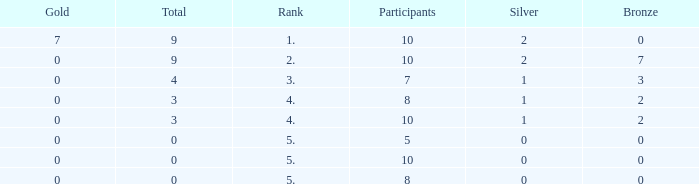What is the total number of Participants that has Silver that's smaller than 0? None. Parse the full table. {'header': ['Gold', 'Total', 'Rank', 'Participants', 'Silver', 'Bronze'], 'rows': [['7', '9', '1.', '10', '2', '0'], ['0', '9', '2.', '10', '2', '7'], ['0', '4', '3.', '7', '1', '3'], ['0', '3', '4.', '8', '1', '2'], ['0', '3', '4.', '10', '1', '2'], ['0', '0', '5.', '5', '0', '0'], ['0', '0', '5.', '10', '0', '0'], ['0', '0', '5.', '8', '0', '0']]} 